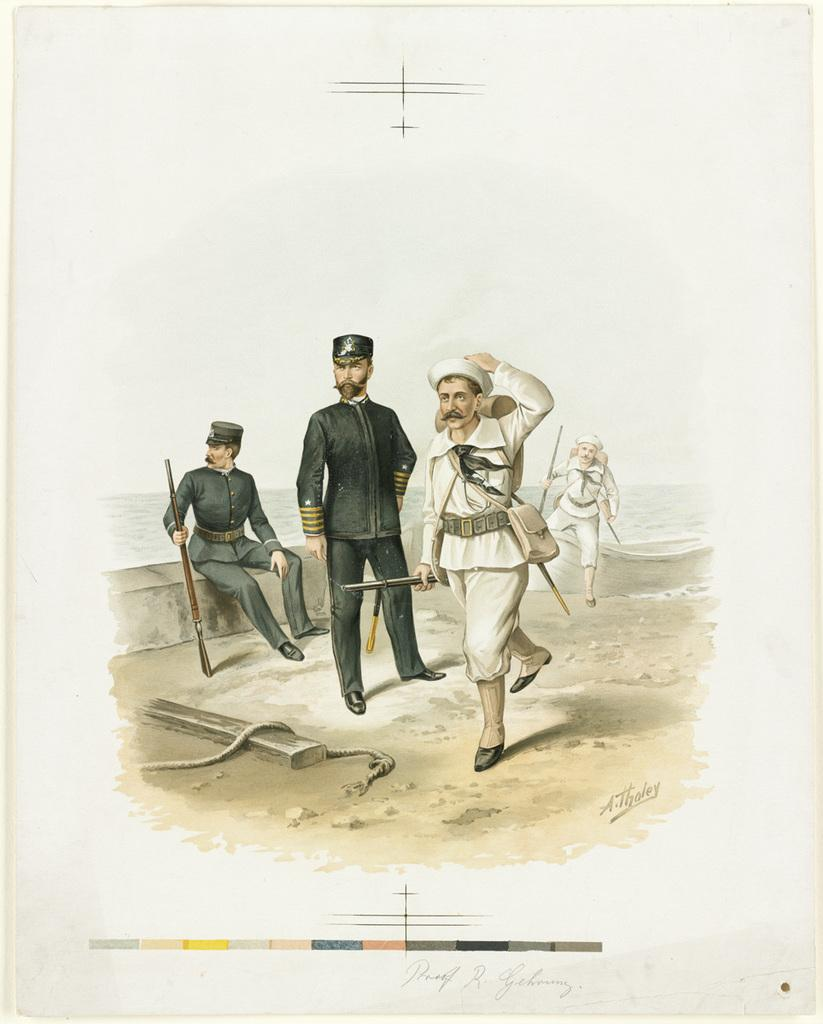What type of artwork is depicted in the image? The image is a painting. Can you describe the subjects in the painting? There are people in the painting. What are some of the people in the painting doing? Some people in the painting are holding guns, wearing uniforms, and carrying bags. Is there any text visible in the painting? Yes, there is text visible in the painting. What is the setting of the painting? There is water in the painting. How many ladybugs can be seen on the uniforms of the people in the painting? There are no ladybugs visible on the uniforms of the people in the painting. What type of drain is present in the water in the painting? There is no drain present in the water in the painting. 